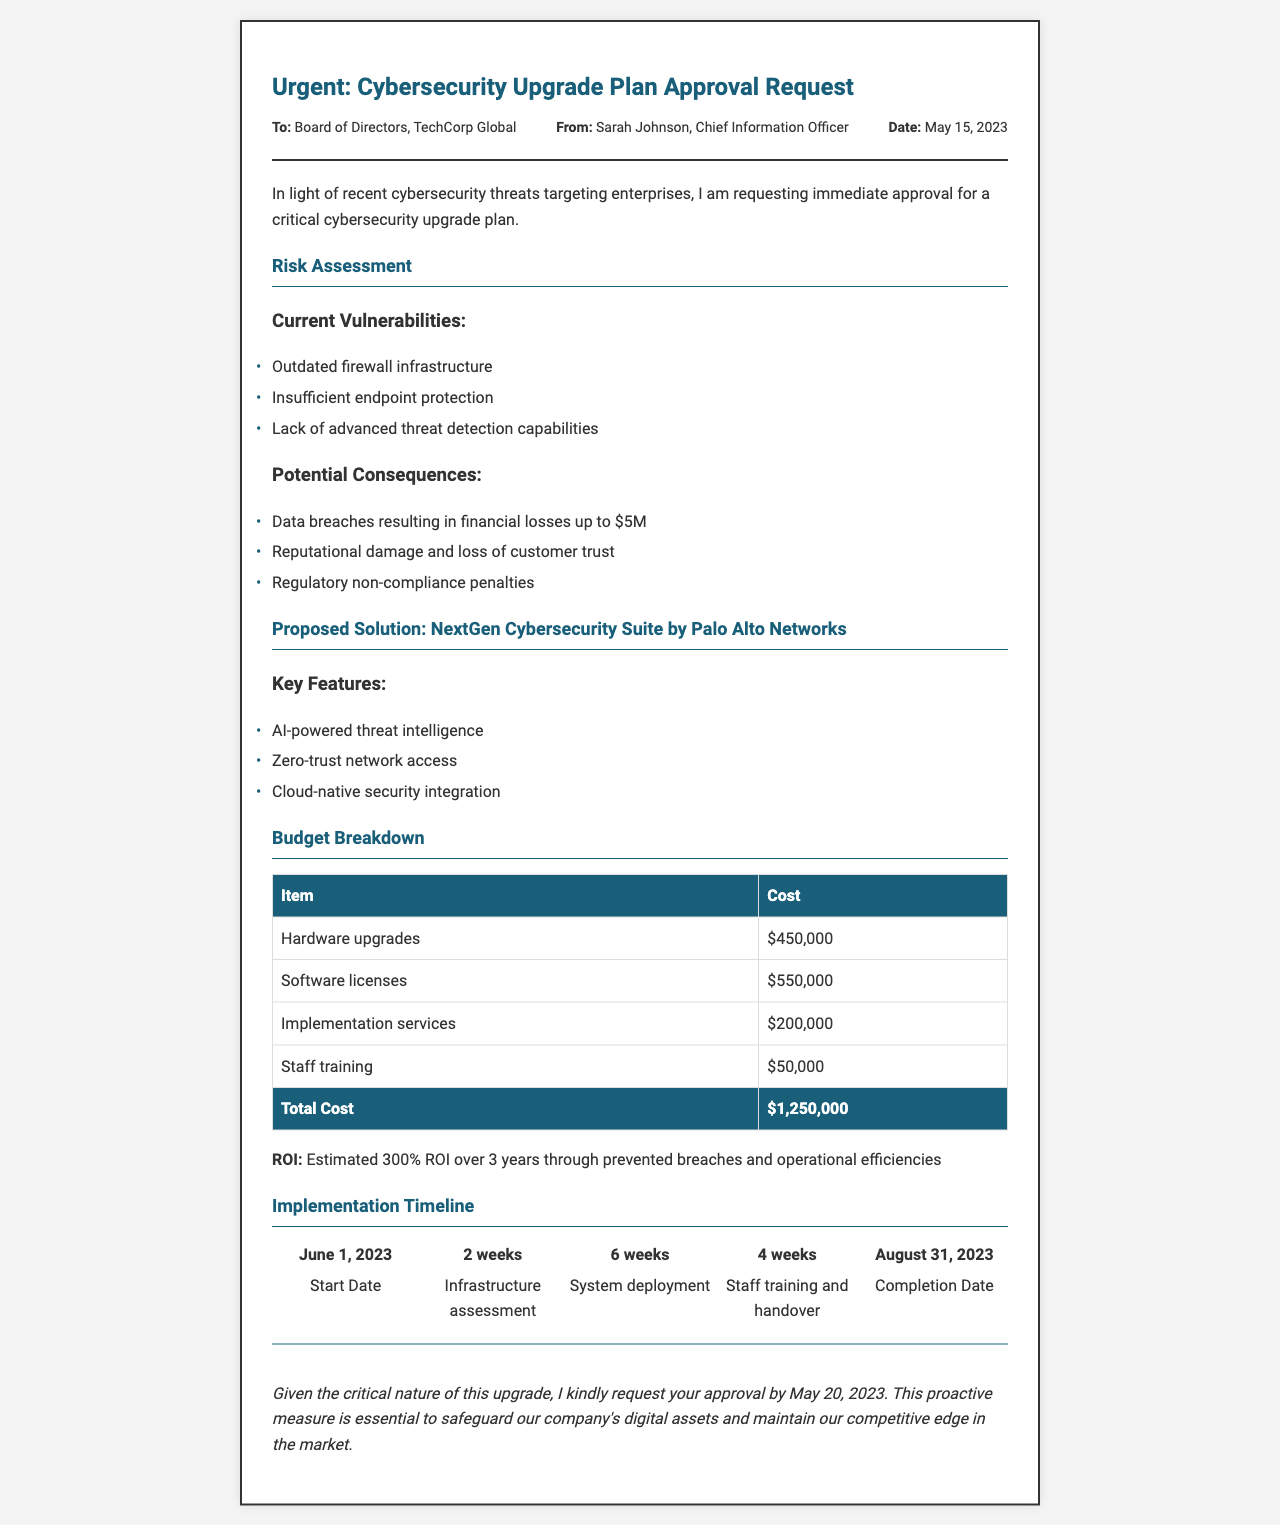what is the request date? The request date provided in the document is May 15, 2023.
Answer: May 15, 2023 who is the sender of the request? The sender mentioned in the document is Sarah Johnson, Chief Information Officer.
Answer: Sarah Johnson what is the total cost of the cybersecurity upgrade plan? The total cost is clearly stated in the budget breakdown section as $1,250,000.
Answer: $1,250,000 what is the first task in the implementation timeline? The first task listed in the implementation timeline is the start date, which is June 1, 2023.
Answer: June 1, 2023 what are two current vulnerabilities mentioned? The document lists outdated firewall infrastructure and insufficient endpoint protection as current vulnerabilities.
Answer: Outdated firewall infrastructure, insufficient endpoint protection what is the estimated ROI over three years? The document states that the estimated ROI is 300% over 3 years.
Answer: 300% what is a potential consequence of current vulnerabilities? The document mentions data breaches resulting in financial losses up to $5 million as a consequence.
Answer: Financial losses up to $5M who is the cybersecurity solution provider proposed in the document? The proposed solution provider mentioned is Palo Alto Networks.
Answer: Palo Alto Networks what is the completion date of the project? The completion date for the project listed in the timeline is August 31, 2023.
Answer: August 31, 2023 